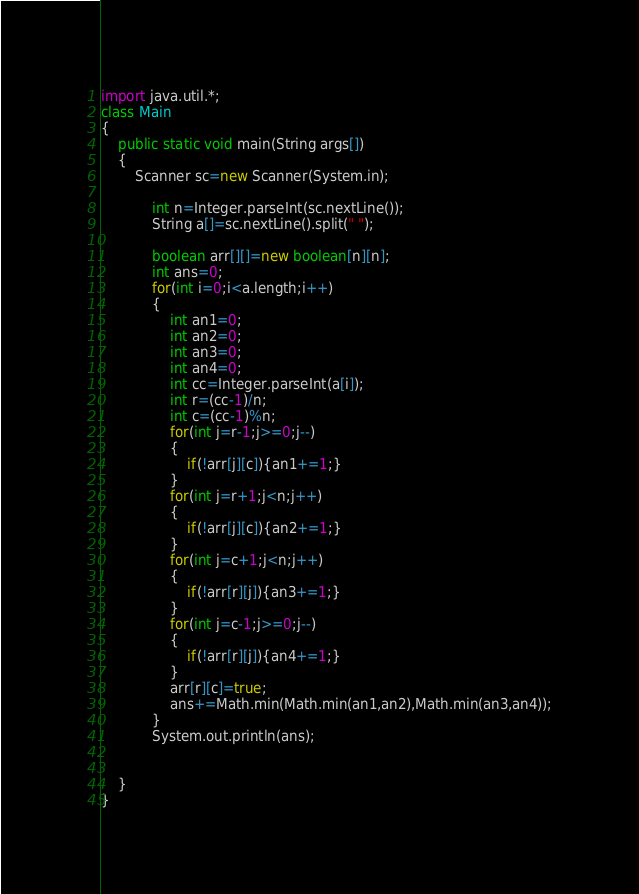<code> <loc_0><loc_0><loc_500><loc_500><_Java_>import java.util.*;
class Main
{
	public static void main(String args[])
	{
		Scanner sc=new Scanner(System.in);
		
			int n=Integer.parseInt(sc.nextLine());
			String a[]=sc.nextLine().split(" ");
			
			boolean arr[][]=new boolean[n][n];
			int ans=0;
			for(int i=0;i<a.length;i++)
			{
				int an1=0;
				int an2=0;
				int an3=0;
				int an4=0;
				int cc=Integer.parseInt(a[i]);
				int r=(cc-1)/n;
				int c=(cc-1)%n;
				for(int j=r-1;j>=0;j--)
				{
					if(!arr[j][c]){an1+=1;}
				}
				for(int j=r+1;j<n;j++)
				{
					if(!arr[j][c]){an2+=1;}
				}
				for(int j=c+1;j<n;j++)
				{
					if(!arr[r][j]){an3+=1;}
				}
				for(int j=c-1;j>=0;j--)
				{
					if(!arr[r][j]){an4+=1;}
				}
				arr[r][c]=true;
				ans+=Math.min(Math.min(an1,an2),Math.min(an3,an4));
			}
			System.out.println(ans);

		
	}
}</code> 